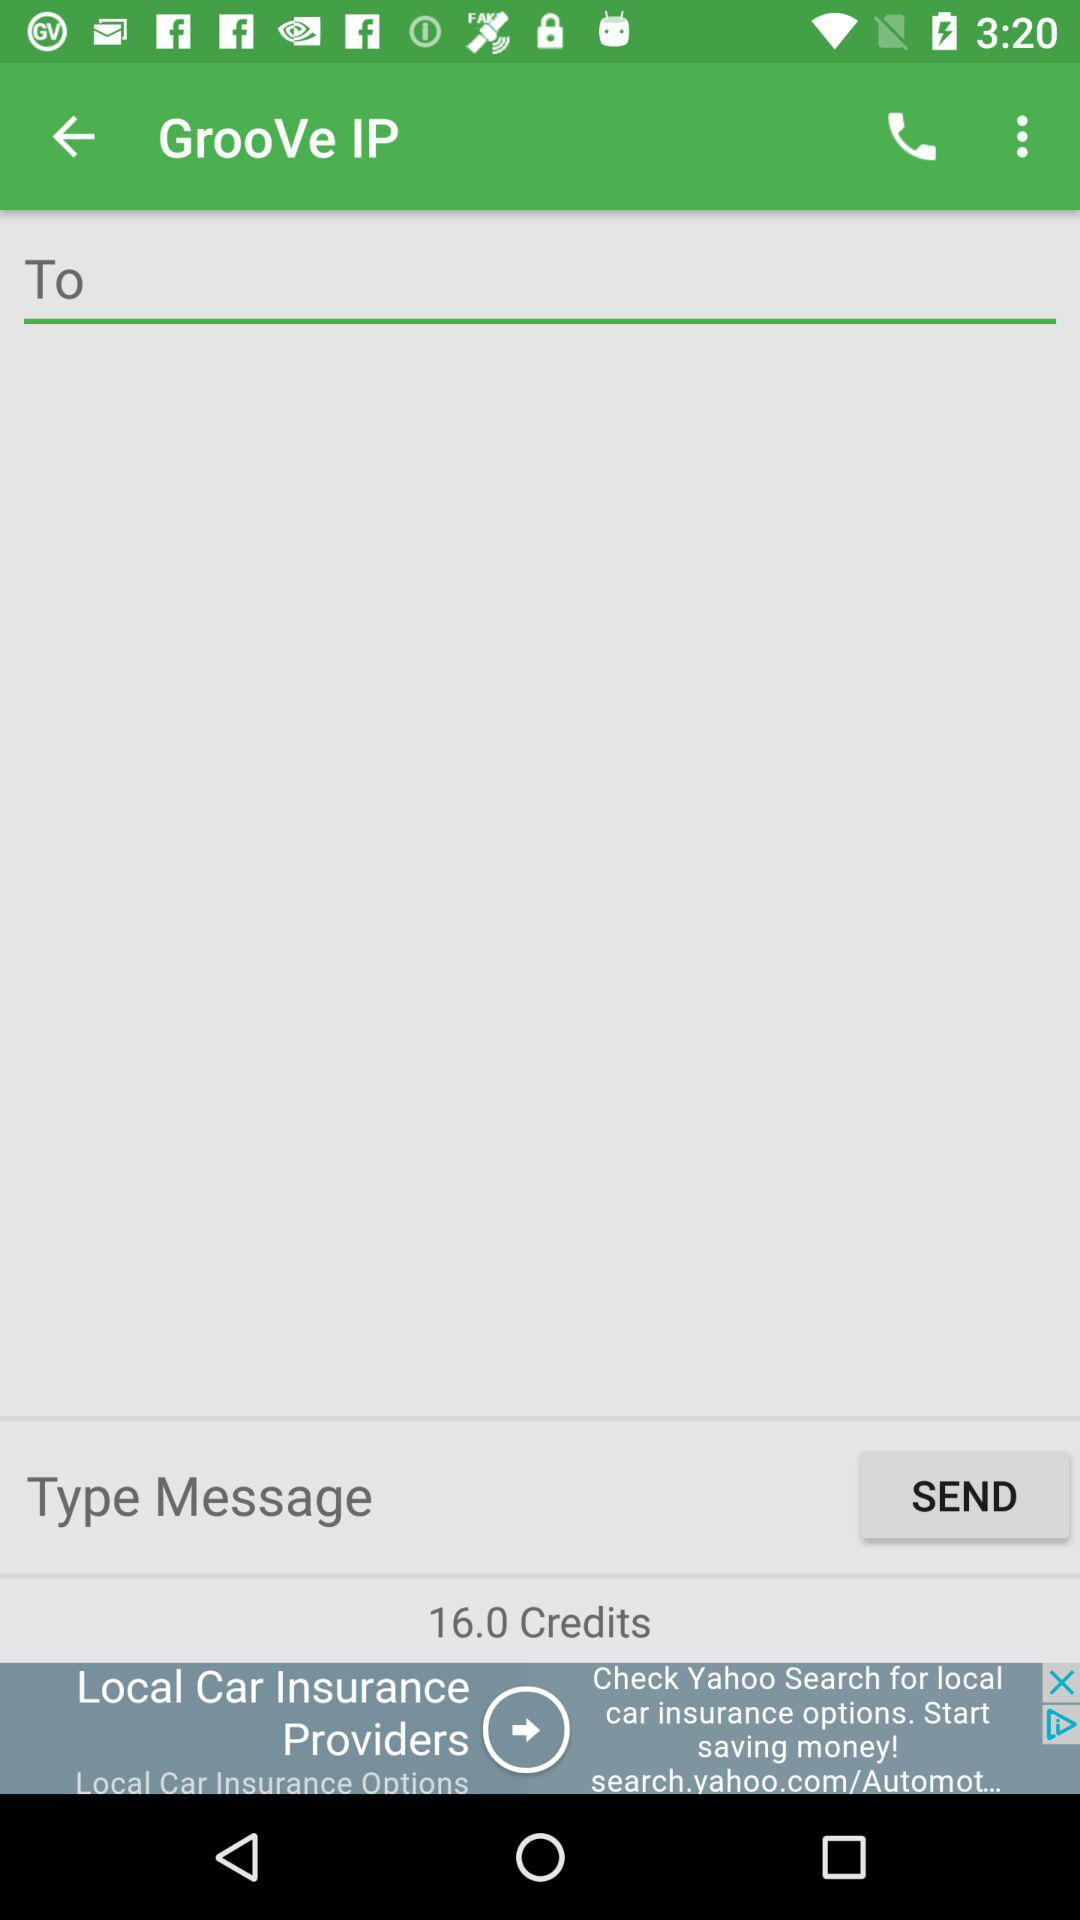What is the name of the application? The name of the application is "GrooVe IP". 